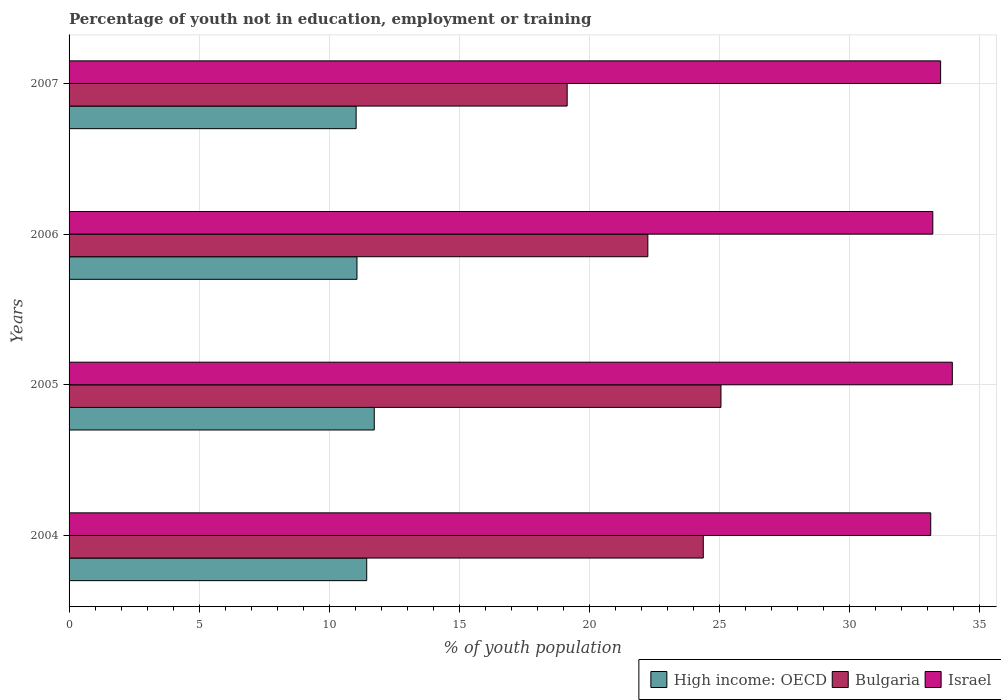How many different coloured bars are there?
Your response must be concise. 3. How many groups of bars are there?
Your answer should be compact. 4. Are the number of bars on each tick of the Y-axis equal?
Your answer should be compact. Yes. How many bars are there on the 3rd tick from the bottom?
Give a very brief answer. 3. What is the label of the 3rd group of bars from the top?
Keep it short and to the point. 2005. What is the percentage of unemployed youth population in in High income: OECD in 2004?
Your answer should be very brief. 11.44. Across all years, what is the maximum percentage of unemployed youth population in in Israel?
Make the answer very short. 33.94. Across all years, what is the minimum percentage of unemployed youth population in in High income: OECD?
Provide a short and direct response. 11.03. In which year was the percentage of unemployed youth population in in High income: OECD maximum?
Provide a short and direct response. 2005. In which year was the percentage of unemployed youth population in in Israel minimum?
Your answer should be compact. 2004. What is the total percentage of unemployed youth population in in High income: OECD in the graph?
Provide a short and direct response. 45.26. What is the difference between the percentage of unemployed youth population in in Bulgaria in 2004 and that in 2006?
Offer a terse response. 2.13. What is the difference between the percentage of unemployed youth population in in High income: OECD in 2006 and the percentage of unemployed youth population in in Israel in 2005?
Your answer should be compact. -22.88. What is the average percentage of unemployed youth population in in Israel per year?
Your response must be concise. 33.43. In the year 2007, what is the difference between the percentage of unemployed youth population in in Bulgaria and percentage of unemployed youth population in in High income: OECD?
Give a very brief answer. 8.11. What is the ratio of the percentage of unemployed youth population in in High income: OECD in 2005 to that in 2007?
Keep it short and to the point. 1.06. Is the difference between the percentage of unemployed youth population in in Bulgaria in 2004 and 2005 greater than the difference between the percentage of unemployed youth population in in High income: OECD in 2004 and 2005?
Ensure brevity in your answer.  No. What is the difference between the highest and the second highest percentage of unemployed youth population in in Israel?
Give a very brief answer. 0.45. What is the difference between the highest and the lowest percentage of unemployed youth population in in Israel?
Offer a very short reply. 0.83. Is the sum of the percentage of unemployed youth population in in Bulgaria in 2004 and 2005 greater than the maximum percentage of unemployed youth population in in High income: OECD across all years?
Make the answer very short. Yes. What does the 3rd bar from the top in 2005 represents?
Your answer should be compact. High income: OECD. Are all the bars in the graph horizontal?
Provide a short and direct response. Yes. How many years are there in the graph?
Ensure brevity in your answer.  4. Are the values on the major ticks of X-axis written in scientific E-notation?
Make the answer very short. No. Does the graph contain any zero values?
Offer a terse response. No. Does the graph contain grids?
Make the answer very short. Yes. Where does the legend appear in the graph?
Your answer should be compact. Bottom right. How many legend labels are there?
Make the answer very short. 3. How are the legend labels stacked?
Keep it short and to the point. Horizontal. What is the title of the graph?
Offer a very short reply. Percentage of youth not in education, employment or training. What is the label or title of the X-axis?
Provide a succinct answer. % of youth population. What is the % of youth population in High income: OECD in 2004?
Your answer should be very brief. 11.44. What is the % of youth population in Bulgaria in 2004?
Your answer should be very brief. 24.37. What is the % of youth population in Israel in 2004?
Your answer should be very brief. 33.11. What is the % of youth population of High income: OECD in 2005?
Provide a succinct answer. 11.73. What is the % of youth population of Bulgaria in 2005?
Provide a short and direct response. 25.05. What is the % of youth population of Israel in 2005?
Make the answer very short. 33.94. What is the % of youth population in High income: OECD in 2006?
Ensure brevity in your answer.  11.06. What is the % of youth population of Bulgaria in 2006?
Keep it short and to the point. 22.24. What is the % of youth population of Israel in 2006?
Offer a terse response. 33.19. What is the % of youth population of High income: OECD in 2007?
Keep it short and to the point. 11.03. What is the % of youth population of Bulgaria in 2007?
Offer a very short reply. 19.14. What is the % of youth population in Israel in 2007?
Ensure brevity in your answer.  33.49. Across all years, what is the maximum % of youth population of High income: OECD?
Your answer should be very brief. 11.73. Across all years, what is the maximum % of youth population in Bulgaria?
Provide a short and direct response. 25.05. Across all years, what is the maximum % of youth population in Israel?
Your answer should be very brief. 33.94. Across all years, what is the minimum % of youth population of High income: OECD?
Give a very brief answer. 11.03. Across all years, what is the minimum % of youth population in Bulgaria?
Provide a short and direct response. 19.14. Across all years, what is the minimum % of youth population of Israel?
Provide a succinct answer. 33.11. What is the total % of youth population in High income: OECD in the graph?
Make the answer very short. 45.26. What is the total % of youth population in Bulgaria in the graph?
Your response must be concise. 90.8. What is the total % of youth population in Israel in the graph?
Your answer should be compact. 133.73. What is the difference between the % of youth population of High income: OECD in 2004 and that in 2005?
Your answer should be compact. -0.29. What is the difference between the % of youth population of Bulgaria in 2004 and that in 2005?
Ensure brevity in your answer.  -0.68. What is the difference between the % of youth population in Israel in 2004 and that in 2005?
Ensure brevity in your answer.  -0.83. What is the difference between the % of youth population of High income: OECD in 2004 and that in 2006?
Provide a short and direct response. 0.37. What is the difference between the % of youth population of Bulgaria in 2004 and that in 2006?
Keep it short and to the point. 2.13. What is the difference between the % of youth population in Israel in 2004 and that in 2006?
Ensure brevity in your answer.  -0.08. What is the difference between the % of youth population in High income: OECD in 2004 and that in 2007?
Your answer should be very brief. 0.41. What is the difference between the % of youth population of Bulgaria in 2004 and that in 2007?
Make the answer very short. 5.23. What is the difference between the % of youth population of Israel in 2004 and that in 2007?
Offer a very short reply. -0.38. What is the difference between the % of youth population in High income: OECD in 2005 and that in 2006?
Keep it short and to the point. 0.66. What is the difference between the % of youth population of Bulgaria in 2005 and that in 2006?
Ensure brevity in your answer.  2.81. What is the difference between the % of youth population in High income: OECD in 2005 and that in 2007?
Provide a succinct answer. 0.7. What is the difference between the % of youth population of Bulgaria in 2005 and that in 2007?
Your response must be concise. 5.91. What is the difference between the % of youth population of Israel in 2005 and that in 2007?
Give a very brief answer. 0.45. What is the difference between the % of youth population of High income: OECD in 2006 and that in 2007?
Give a very brief answer. 0.03. What is the difference between the % of youth population of Bulgaria in 2006 and that in 2007?
Your answer should be very brief. 3.1. What is the difference between the % of youth population of Israel in 2006 and that in 2007?
Your response must be concise. -0.3. What is the difference between the % of youth population in High income: OECD in 2004 and the % of youth population in Bulgaria in 2005?
Your answer should be very brief. -13.61. What is the difference between the % of youth population of High income: OECD in 2004 and the % of youth population of Israel in 2005?
Your answer should be very brief. -22.5. What is the difference between the % of youth population in Bulgaria in 2004 and the % of youth population in Israel in 2005?
Offer a terse response. -9.57. What is the difference between the % of youth population of High income: OECD in 2004 and the % of youth population of Bulgaria in 2006?
Give a very brief answer. -10.8. What is the difference between the % of youth population of High income: OECD in 2004 and the % of youth population of Israel in 2006?
Provide a succinct answer. -21.75. What is the difference between the % of youth population of Bulgaria in 2004 and the % of youth population of Israel in 2006?
Offer a very short reply. -8.82. What is the difference between the % of youth population of High income: OECD in 2004 and the % of youth population of Bulgaria in 2007?
Make the answer very short. -7.7. What is the difference between the % of youth population in High income: OECD in 2004 and the % of youth population in Israel in 2007?
Your answer should be very brief. -22.05. What is the difference between the % of youth population in Bulgaria in 2004 and the % of youth population in Israel in 2007?
Make the answer very short. -9.12. What is the difference between the % of youth population of High income: OECD in 2005 and the % of youth population of Bulgaria in 2006?
Your answer should be compact. -10.51. What is the difference between the % of youth population in High income: OECD in 2005 and the % of youth population in Israel in 2006?
Offer a very short reply. -21.46. What is the difference between the % of youth population in Bulgaria in 2005 and the % of youth population in Israel in 2006?
Give a very brief answer. -8.14. What is the difference between the % of youth population in High income: OECD in 2005 and the % of youth population in Bulgaria in 2007?
Offer a terse response. -7.41. What is the difference between the % of youth population in High income: OECD in 2005 and the % of youth population in Israel in 2007?
Your answer should be very brief. -21.76. What is the difference between the % of youth population of Bulgaria in 2005 and the % of youth population of Israel in 2007?
Ensure brevity in your answer.  -8.44. What is the difference between the % of youth population of High income: OECD in 2006 and the % of youth population of Bulgaria in 2007?
Offer a very short reply. -8.08. What is the difference between the % of youth population in High income: OECD in 2006 and the % of youth population in Israel in 2007?
Provide a succinct answer. -22.43. What is the difference between the % of youth population of Bulgaria in 2006 and the % of youth population of Israel in 2007?
Your answer should be very brief. -11.25. What is the average % of youth population in High income: OECD per year?
Keep it short and to the point. 11.31. What is the average % of youth population in Bulgaria per year?
Make the answer very short. 22.7. What is the average % of youth population in Israel per year?
Provide a short and direct response. 33.43. In the year 2004, what is the difference between the % of youth population of High income: OECD and % of youth population of Bulgaria?
Keep it short and to the point. -12.93. In the year 2004, what is the difference between the % of youth population of High income: OECD and % of youth population of Israel?
Your answer should be very brief. -21.67. In the year 2004, what is the difference between the % of youth population in Bulgaria and % of youth population in Israel?
Your response must be concise. -8.74. In the year 2005, what is the difference between the % of youth population in High income: OECD and % of youth population in Bulgaria?
Keep it short and to the point. -13.32. In the year 2005, what is the difference between the % of youth population in High income: OECD and % of youth population in Israel?
Your answer should be compact. -22.21. In the year 2005, what is the difference between the % of youth population of Bulgaria and % of youth population of Israel?
Offer a very short reply. -8.89. In the year 2006, what is the difference between the % of youth population of High income: OECD and % of youth population of Bulgaria?
Your response must be concise. -11.18. In the year 2006, what is the difference between the % of youth population of High income: OECD and % of youth population of Israel?
Make the answer very short. -22.13. In the year 2006, what is the difference between the % of youth population in Bulgaria and % of youth population in Israel?
Make the answer very short. -10.95. In the year 2007, what is the difference between the % of youth population in High income: OECD and % of youth population in Bulgaria?
Your response must be concise. -8.11. In the year 2007, what is the difference between the % of youth population of High income: OECD and % of youth population of Israel?
Provide a succinct answer. -22.46. In the year 2007, what is the difference between the % of youth population in Bulgaria and % of youth population in Israel?
Offer a very short reply. -14.35. What is the ratio of the % of youth population in High income: OECD in 2004 to that in 2005?
Provide a short and direct response. 0.98. What is the ratio of the % of youth population in Bulgaria in 2004 to that in 2005?
Give a very brief answer. 0.97. What is the ratio of the % of youth population in Israel in 2004 to that in 2005?
Offer a very short reply. 0.98. What is the ratio of the % of youth population of High income: OECD in 2004 to that in 2006?
Keep it short and to the point. 1.03. What is the ratio of the % of youth population of Bulgaria in 2004 to that in 2006?
Your response must be concise. 1.1. What is the ratio of the % of youth population of Israel in 2004 to that in 2006?
Ensure brevity in your answer.  1. What is the ratio of the % of youth population in High income: OECD in 2004 to that in 2007?
Provide a succinct answer. 1.04. What is the ratio of the % of youth population of Bulgaria in 2004 to that in 2007?
Give a very brief answer. 1.27. What is the ratio of the % of youth population of Israel in 2004 to that in 2007?
Your response must be concise. 0.99. What is the ratio of the % of youth population in High income: OECD in 2005 to that in 2006?
Ensure brevity in your answer.  1.06. What is the ratio of the % of youth population of Bulgaria in 2005 to that in 2006?
Your answer should be very brief. 1.13. What is the ratio of the % of youth population of Israel in 2005 to that in 2006?
Ensure brevity in your answer.  1.02. What is the ratio of the % of youth population of High income: OECD in 2005 to that in 2007?
Make the answer very short. 1.06. What is the ratio of the % of youth population of Bulgaria in 2005 to that in 2007?
Ensure brevity in your answer.  1.31. What is the ratio of the % of youth population in Israel in 2005 to that in 2007?
Your answer should be compact. 1.01. What is the ratio of the % of youth population of Bulgaria in 2006 to that in 2007?
Make the answer very short. 1.16. What is the difference between the highest and the second highest % of youth population of High income: OECD?
Give a very brief answer. 0.29. What is the difference between the highest and the second highest % of youth population in Bulgaria?
Keep it short and to the point. 0.68. What is the difference between the highest and the second highest % of youth population of Israel?
Your answer should be very brief. 0.45. What is the difference between the highest and the lowest % of youth population in High income: OECD?
Ensure brevity in your answer.  0.7. What is the difference between the highest and the lowest % of youth population of Bulgaria?
Your response must be concise. 5.91. What is the difference between the highest and the lowest % of youth population in Israel?
Give a very brief answer. 0.83. 